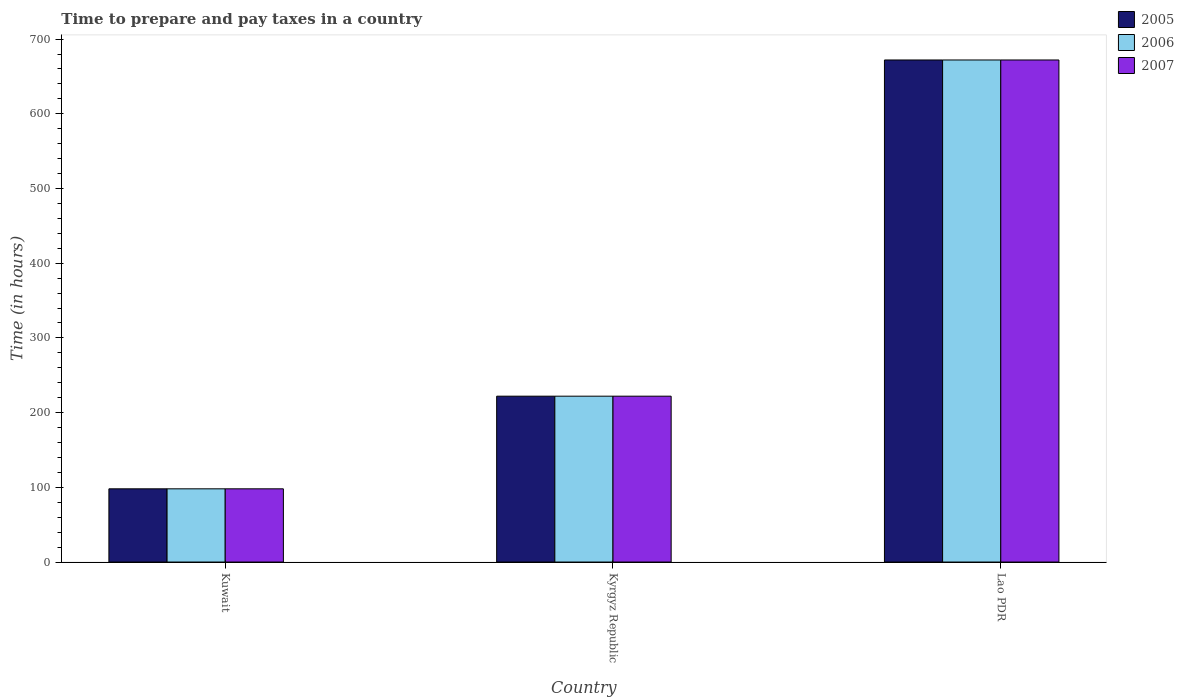How many different coloured bars are there?
Make the answer very short. 3. How many groups of bars are there?
Provide a succinct answer. 3. Are the number of bars on each tick of the X-axis equal?
Keep it short and to the point. Yes. How many bars are there on the 2nd tick from the right?
Offer a very short reply. 3. What is the label of the 3rd group of bars from the left?
Provide a short and direct response. Lao PDR. Across all countries, what is the maximum number of hours required to prepare and pay taxes in 2007?
Offer a terse response. 672. In which country was the number of hours required to prepare and pay taxes in 2005 maximum?
Offer a very short reply. Lao PDR. In which country was the number of hours required to prepare and pay taxes in 2006 minimum?
Give a very brief answer. Kuwait. What is the total number of hours required to prepare and pay taxes in 2006 in the graph?
Your answer should be very brief. 992. What is the difference between the number of hours required to prepare and pay taxes in 2007 in Kuwait and that in Kyrgyz Republic?
Provide a succinct answer. -124. What is the difference between the number of hours required to prepare and pay taxes in 2007 in Kyrgyz Republic and the number of hours required to prepare and pay taxes in 2006 in Lao PDR?
Offer a very short reply. -450. What is the average number of hours required to prepare and pay taxes in 2007 per country?
Ensure brevity in your answer.  330.67. What is the difference between the number of hours required to prepare and pay taxes of/in 2006 and number of hours required to prepare and pay taxes of/in 2007 in Kuwait?
Provide a succinct answer. 0. In how many countries, is the number of hours required to prepare and pay taxes in 2005 greater than 420 hours?
Make the answer very short. 1. What is the ratio of the number of hours required to prepare and pay taxes in 2007 in Kuwait to that in Kyrgyz Republic?
Keep it short and to the point. 0.44. Is the number of hours required to prepare and pay taxes in 2005 in Kuwait less than that in Kyrgyz Republic?
Offer a terse response. Yes. What is the difference between the highest and the second highest number of hours required to prepare and pay taxes in 2006?
Offer a very short reply. 574. What is the difference between the highest and the lowest number of hours required to prepare and pay taxes in 2007?
Keep it short and to the point. 574. Is it the case that in every country, the sum of the number of hours required to prepare and pay taxes in 2005 and number of hours required to prepare and pay taxes in 2006 is greater than the number of hours required to prepare and pay taxes in 2007?
Your answer should be compact. Yes. How many bars are there?
Offer a very short reply. 9. How many legend labels are there?
Offer a terse response. 3. What is the title of the graph?
Offer a terse response. Time to prepare and pay taxes in a country. What is the label or title of the Y-axis?
Offer a terse response. Time (in hours). What is the Time (in hours) in 2005 in Kuwait?
Your response must be concise. 98. What is the Time (in hours) of 2006 in Kuwait?
Your answer should be compact. 98. What is the Time (in hours) in 2005 in Kyrgyz Republic?
Keep it short and to the point. 222. What is the Time (in hours) of 2006 in Kyrgyz Republic?
Your response must be concise. 222. What is the Time (in hours) in 2007 in Kyrgyz Republic?
Keep it short and to the point. 222. What is the Time (in hours) in 2005 in Lao PDR?
Make the answer very short. 672. What is the Time (in hours) in 2006 in Lao PDR?
Ensure brevity in your answer.  672. What is the Time (in hours) in 2007 in Lao PDR?
Make the answer very short. 672. Across all countries, what is the maximum Time (in hours) in 2005?
Offer a terse response. 672. Across all countries, what is the maximum Time (in hours) of 2006?
Provide a succinct answer. 672. Across all countries, what is the maximum Time (in hours) in 2007?
Ensure brevity in your answer.  672. Across all countries, what is the minimum Time (in hours) of 2007?
Your answer should be compact. 98. What is the total Time (in hours) in 2005 in the graph?
Provide a short and direct response. 992. What is the total Time (in hours) of 2006 in the graph?
Make the answer very short. 992. What is the total Time (in hours) of 2007 in the graph?
Keep it short and to the point. 992. What is the difference between the Time (in hours) of 2005 in Kuwait and that in Kyrgyz Republic?
Offer a very short reply. -124. What is the difference between the Time (in hours) of 2006 in Kuwait and that in Kyrgyz Republic?
Offer a very short reply. -124. What is the difference between the Time (in hours) of 2007 in Kuwait and that in Kyrgyz Republic?
Offer a terse response. -124. What is the difference between the Time (in hours) in 2005 in Kuwait and that in Lao PDR?
Offer a very short reply. -574. What is the difference between the Time (in hours) in 2006 in Kuwait and that in Lao PDR?
Ensure brevity in your answer.  -574. What is the difference between the Time (in hours) of 2007 in Kuwait and that in Lao PDR?
Offer a very short reply. -574. What is the difference between the Time (in hours) of 2005 in Kyrgyz Republic and that in Lao PDR?
Offer a very short reply. -450. What is the difference between the Time (in hours) in 2006 in Kyrgyz Republic and that in Lao PDR?
Provide a short and direct response. -450. What is the difference between the Time (in hours) of 2007 in Kyrgyz Republic and that in Lao PDR?
Give a very brief answer. -450. What is the difference between the Time (in hours) in 2005 in Kuwait and the Time (in hours) in 2006 in Kyrgyz Republic?
Your response must be concise. -124. What is the difference between the Time (in hours) in 2005 in Kuwait and the Time (in hours) in 2007 in Kyrgyz Republic?
Keep it short and to the point. -124. What is the difference between the Time (in hours) of 2006 in Kuwait and the Time (in hours) of 2007 in Kyrgyz Republic?
Provide a succinct answer. -124. What is the difference between the Time (in hours) of 2005 in Kuwait and the Time (in hours) of 2006 in Lao PDR?
Your answer should be compact. -574. What is the difference between the Time (in hours) in 2005 in Kuwait and the Time (in hours) in 2007 in Lao PDR?
Your response must be concise. -574. What is the difference between the Time (in hours) of 2006 in Kuwait and the Time (in hours) of 2007 in Lao PDR?
Provide a short and direct response. -574. What is the difference between the Time (in hours) in 2005 in Kyrgyz Republic and the Time (in hours) in 2006 in Lao PDR?
Offer a very short reply. -450. What is the difference between the Time (in hours) of 2005 in Kyrgyz Republic and the Time (in hours) of 2007 in Lao PDR?
Keep it short and to the point. -450. What is the difference between the Time (in hours) of 2006 in Kyrgyz Republic and the Time (in hours) of 2007 in Lao PDR?
Give a very brief answer. -450. What is the average Time (in hours) in 2005 per country?
Your answer should be very brief. 330.67. What is the average Time (in hours) in 2006 per country?
Your response must be concise. 330.67. What is the average Time (in hours) of 2007 per country?
Ensure brevity in your answer.  330.67. What is the difference between the Time (in hours) in 2005 and Time (in hours) in 2006 in Kuwait?
Your answer should be very brief. 0. What is the difference between the Time (in hours) in 2005 and Time (in hours) in 2006 in Kyrgyz Republic?
Your answer should be compact. 0. What is the difference between the Time (in hours) of 2005 and Time (in hours) of 2007 in Kyrgyz Republic?
Keep it short and to the point. 0. What is the ratio of the Time (in hours) of 2005 in Kuwait to that in Kyrgyz Republic?
Your answer should be compact. 0.44. What is the ratio of the Time (in hours) in 2006 in Kuwait to that in Kyrgyz Republic?
Provide a short and direct response. 0.44. What is the ratio of the Time (in hours) in 2007 in Kuwait to that in Kyrgyz Republic?
Make the answer very short. 0.44. What is the ratio of the Time (in hours) of 2005 in Kuwait to that in Lao PDR?
Offer a terse response. 0.15. What is the ratio of the Time (in hours) in 2006 in Kuwait to that in Lao PDR?
Keep it short and to the point. 0.15. What is the ratio of the Time (in hours) of 2007 in Kuwait to that in Lao PDR?
Your answer should be very brief. 0.15. What is the ratio of the Time (in hours) of 2005 in Kyrgyz Republic to that in Lao PDR?
Offer a very short reply. 0.33. What is the ratio of the Time (in hours) in 2006 in Kyrgyz Republic to that in Lao PDR?
Provide a succinct answer. 0.33. What is the ratio of the Time (in hours) of 2007 in Kyrgyz Republic to that in Lao PDR?
Ensure brevity in your answer.  0.33. What is the difference between the highest and the second highest Time (in hours) of 2005?
Make the answer very short. 450. What is the difference between the highest and the second highest Time (in hours) of 2006?
Make the answer very short. 450. What is the difference between the highest and the second highest Time (in hours) in 2007?
Offer a very short reply. 450. What is the difference between the highest and the lowest Time (in hours) of 2005?
Make the answer very short. 574. What is the difference between the highest and the lowest Time (in hours) in 2006?
Provide a short and direct response. 574. What is the difference between the highest and the lowest Time (in hours) of 2007?
Offer a terse response. 574. 